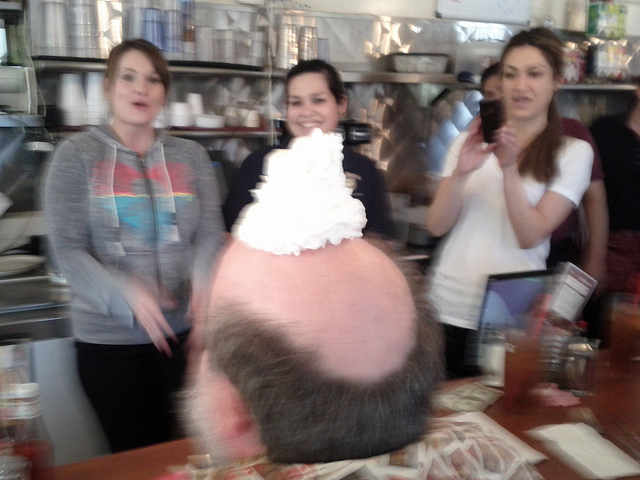What does the woman do with her phone?
A. text
B. auto dial
C. take photo
D. call
Answer with the option's letter from the given choices directly. C 